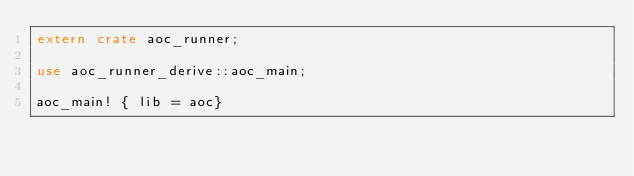Convert code to text. <code><loc_0><loc_0><loc_500><loc_500><_Rust_>extern crate aoc_runner;

use aoc_runner_derive::aoc_main;

aoc_main! { lib = aoc}
</code> 